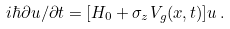<formula> <loc_0><loc_0><loc_500><loc_500>i \hbar { \partial } { u } / \partial t = [ { H } _ { 0 } + \sigma _ { z } V _ { g } ( x , t ) ] { u } \, .</formula> 